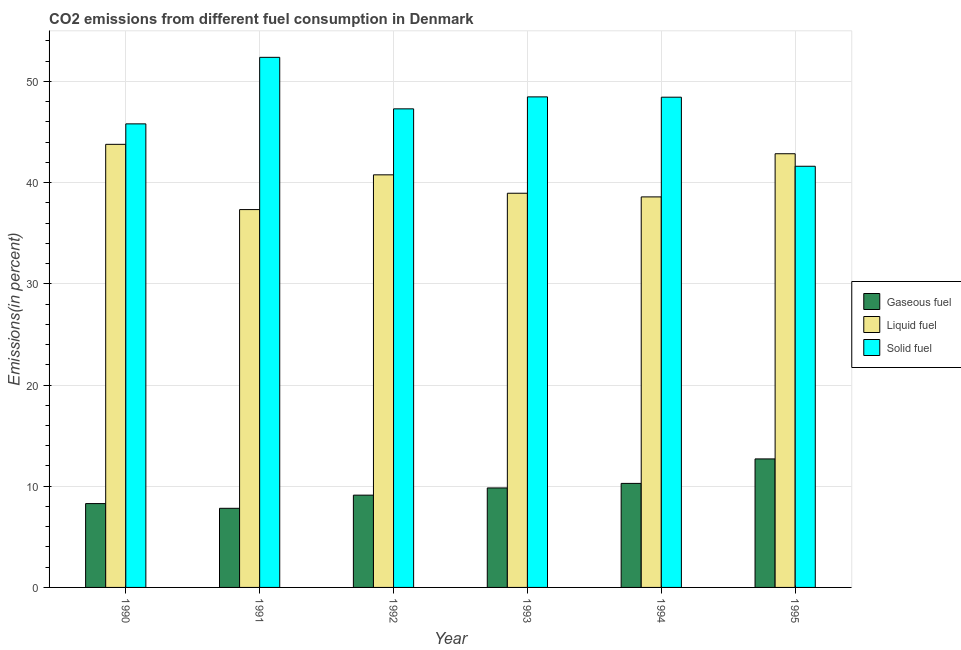How many different coloured bars are there?
Provide a short and direct response. 3. Are the number of bars per tick equal to the number of legend labels?
Your response must be concise. Yes. How many bars are there on the 2nd tick from the left?
Give a very brief answer. 3. What is the label of the 5th group of bars from the left?
Provide a succinct answer. 1994. In how many cases, is the number of bars for a given year not equal to the number of legend labels?
Offer a very short reply. 0. What is the percentage of gaseous fuel emission in 1995?
Make the answer very short. 12.7. Across all years, what is the maximum percentage of solid fuel emission?
Make the answer very short. 52.39. Across all years, what is the minimum percentage of liquid fuel emission?
Your response must be concise. 37.34. What is the total percentage of liquid fuel emission in the graph?
Your answer should be very brief. 242.3. What is the difference between the percentage of solid fuel emission in 1993 and that in 1995?
Give a very brief answer. 6.86. What is the difference between the percentage of liquid fuel emission in 1991 and the percentage of gaseous fuel emission in 1992?
Your response must be concise. -3.43. What is the average percentage of liquid fuel emission per year?
Your answer should be very brief. 40.38. What is the ratio of the percentage of liquid fuel emission in 1991 to that in 1995?
Give a very brief answer. 0.87. Is the percentage of liquid fuel emission in 1993 less than that in 1995?
Provide a succinct answer. Yes. Is the difference between the percentage of solid fuel emission in 1991 and 1992 greater than the difference between the percentage of liquid fuel emission in 1991 and 1992?
Keep it short and to the point. No. What is the difference between the highest and the second highest percentage of liquid fuel emission?
Ensure brevity in your answer.  0.93. What is the difference between the highest and the lowest percentage of gaseous fuel emission?
Your answer should be compact. 4.88. What does the 2nd bar from the left in 1992 represents?
Give a very brief answer. Liquid fuel. What does the 2nd bar from the right in 1994 represents?
Give a very brief answer. Liquid fuel. How many bars are there?
Give a very brief answer. 18. What is the difference between two consecutive major ticks on the Y-axis?
Provide a succinct answer. 10. Are the values on the major ticks of Y-axis written in scientific E-notation?
Your response must be concise. No. Does the graph contain any zero values?
Offer a terse response. No. Where does the legend appear in the graph?
Ensure brevity in your answer.  Center right. How are the legend labels stacked?
Offer a terse response. Vertical. What is the title of the graph?
Your answer should be very brief. CO2 emissions from different fuel consumption in Denmark. What is the label or title of the Y-axis?
Your response must be concise. Emissions(in percent). What is the Emissions(in percent) in Gaseous fuel in 1990?
Provide a succinct answer. 8.29. What is the Emissions(in percent) in Liquid fuel in 1990?
Provide a succinct answer. 43.79. What is the Emissions(in percent) in Solid fuel in 1990?
Ensure brevity in your answer.  45.81. What is the Emissions(in percent) in Gaseous fuel in 1991?
Ensure brevity in your answer.  7.82. What is the Emissions(in percent) of Liquid fuel in 1991?
Offer a terse response. 37.34. What is the Emissions(in percent) of Solid fuel in 1991?
Provide a succinct answer. 52.39. What is the Emissions(in percent) in Gaseous fuel in 1992?
Your answer should be very brief. 9.12. What is the Emissions(in percent) of Liquid fuel in 1992?
Provide a short and direct response. 40.77. What is the Emissions(in percent) of Solid fuel in 1992?
Keep it short and to the point. 47.29. What is the Emissions(in percent) in Gaseous fuel in 1993?
Your answer should be very brief. 9.83. What is the Emissions(in percent) in Liquid fuel in 1993?
Offer a very short reply. 38.95. What is the Emissions(in percent) of Solid fuel in 1993?
Offer a terse response. 48.48. What is the Emissions(in percent) in Gaseous fuel in 1994?
Make the answer very short. 10.28. What is the Emissions(in percent) of Liquid fuel in 1994?
Provide a short and direct response. 38.59. What is the Emissions(in percent) in Solid fuel in 1994?
Keep it short and to the point. 48.45. What is the Emissions(in percent) in Gaseous fuel in 1995?
Your response must be concise. 12.7. What is the Emissions(in percent) of Liquid fuel in 1995?
Offer a very short reply. 42.86. What is the Emissions(in percent) of Solid fuel in 1995?
Keep it short and to the point. 41.62. Across all years, what is the maximum Emissions(in percent) in Gaseous fuel?
Your response must be concise. 12.7. Across all years, what is the maximum Emissions(in percent) in Liquid fuel?
Your answer should be compact. 43.79. Across all years, what is the maximum Emissions(in percent) of Solid fuel?
Make the answer very short. 52.39. Across all years, what is the minimum Emissions(in percent) of Gaseous fuel?
Your answer should be compact. 7.82. Across all years, what is the minimum Emissions(in percent) in Liquid fuel?
Keep it short and to the point. 37.34. Across all years, what is the minimum Emissions(in percent) of Solid fuel?
Your answer should be compact. 41.62. What is the total Emissions(in percent) in Gaseous fuel in the graph?
Offer a very short reply. 58.03. What is the total Emissions(in percent) in Liquid fuel in the graph?
Offer a terse response. 242.3. What is the total Emissions(in percent) of Solid fuel in the graph?
Your response must be concise. 284.03. What is the difference between the Emissions(in percent) of Gaseous fuel in 1990 and that in 1991?
Provide a succinct answer. 0.47. What is the difference between the Emissions(in percent) of Liquid fuel in 1990 and that in 1991?
Provide a short and direct response. 6.45. What is the difference between the Emissions(in percent) of Solid fuel in 1990 and that in 1991?
Your answer should be very brief. -6.58. What is the difference between the Emissions(in percent) in Gaseous fuel in 1990 and that in 1992?
Provide a succinct answer. -0.83. What is the difference between the Emissions(in percent) in Liquid fuel in 1990 and that in 1992?
Make the answer very short. 3.02. What is the difference between the Emissions(in percent) in Solid fuel in 1990 and that in 1992?
Keep it short and to the point. -1.48. What is the difference between the Emissions(in percent) of Gaseous fuel in 1990 and that in 1993?
Offer a very short reply. -1.55. What is the difference between the Emissions(in percent) of Liquid fuel in 1990 and that in 1993?
Offer a terse response. 4.83. What is the difference between the Emissions(in percent) in Solid fuel in 1990 and that in 1993?
Offer a terse response. -2.67. What is the difference between the Emissions(in percent) in Gaseous fuel in 1990 and that in 1994?
Your answer should be very brief. -1.99. What is the difference between the Emissions(in percent) in Liquid fuel in 1990 and that in 1994?
Keep it short and to the point. 5.19. What is the difference between the Emissions(in percent) in Solid fuel in 1990 and that in 1994?
Offer a terse response. -2.64. What is the difference between the Emissions(in percent) of Gaseous fuel in 1990 and that in 1995?
Ensure brevity in your answer.  -4.41. What is the difference between the Emissions(in percent) of Liquid fuel in 1990 and that in 1995?
Provide a succinct answer. 0.93. What is the difference between the Emissions(in percent) of Solid fuel in 1990 and that in 1995?
Your response must be concise. 4.19. What is the difference between the Emissions(in percent) of Gaseous fuel in 1991 and that in 1992?
Your response must be concise. -1.3. What is the difference between the Emissions(in percent) of Liquid fuel in 1991 and that in 1992?
Offer a very short reply. -3.43. What is the difference between the Emissions(in percent) in Solid fuel in 1991 and that in 1992?
Give a very brief answer. 5.09. What is the difference between the Emissions(in percent) in Gaseous fuel in 1991 and that in 1993?
Keep it short and to the point. -2.01. What is the difference between the Emissions(in percent) of Liquid fuel in 1991 and that in 1993?
Provide a short and direct response. -1.62. What is the difference between the Emissions(in percent) in Solid fuel in 1991 and that in 1993?
Offer a terse response. 3.91. What is the difference between the Emissions(in percent) in Gaseous fuel in 1991 and that in 1994?
Keep it short and to the point. -2.46. What is the difference between the Emissions(in percent) of Liquid fuel in 1991 and that in 1994?
Your answer should be very brief. -1.25. What is the difference between the Emissions(in percent) of Solid fuel in 1991 and that in 1994?
Your answer should be very brief. 3.94. What is the difference between the Emissions(in percent) of Gaseous fuel in 1991 and that in 1995?
Your response must be concise. -4.88. What is the difference between the Emissions(in percent) of Liquid fuel in 1991 and that in 1995?
Ensure brevity in your answer.  -5.52. What is the difference between the Emissions(in percent) in Solid fuel in 1991 and that in 1995?
Offer a terse response. 10.76. What is the difference between the Emissions(in percent) of Gaseous fuel in 1992 and that in 1993?
Make the answer very short. -0.71. What is the difference between the Emissions(in percent) in Liquid fuel in 1992 and that in 1993?
Give a very brief answer. 1.82. What is the difference between the Emissions(in percent) in Solid fuel in 1992 and that in 1993?
Keep it short and to the point. -1.18. What is the difference between the Emissions(in percent) in Gaseous fuel in 1992 and that in 1994?
Provide a short and direct response. -1.16. What is the difference between the Emissions(in percent) of Liquid fuel in 1992 and that in 1994?
Provide a short and direct response. 2.18. What is the difference between the Emissions(in percent) of Solid fuel in 1992 and that in 1994?
Provide a succinct answer. -1.15. What is the difference between the Emissions(in percent) in Gaseous fuel in 1992 and that in 1995?
Your answer should be very brief. -3.58. What is the difference between the Emissions(in percent) in Liquid fuel in 1992 and that in 1995?
Your answer should be very brief. -2.09. What is the difference between the Emissions(in percent) in Solid fuel in 1992 and that in 1995?
Your answer should be very brief. 5.67. What is the difference between the Emissions(in percent) of Gaseous fuel in 1993 and that in 1994?
Give a very brief answer. -0.45. What is the difference between the Emissions(in percent) of Liquid fuel in 1993 and that in 1994?
Give a very brief answer. 0.36. What is the difference between the Emissions(in percent) in Solid fuel in 1993 and that in 1994?
Keep it short and to the point. 0.03. What is the difference between the Emissions(in percent) in Gaseous fuel in 1993 and that in 1995?
Ensure brevity in your answer.  -2.87. What is the difference between the Emissions(in percent) of Liquid fuel in 1993 and that in 1995?
Keep it short and to the point. -3.9. What is the difference between the Emissions(in percent) of Solid fuel in 1993 and that in 1995?
Offer a very short reply. 6.86. What is the difference between the Emissions(in percent) of Gaseous fuel in 1994 and that in 1995?
Provide a short and direct response. -2.42. What is the difference between the Emissions(in percent) of Liquid fuel in 1994 and that in 1995?
Give a very brief answer. -4.26. What is the difference between the Emissions(in percent) in Solid fuel in 1994 and that in 1995?
Make the answer very short. 6.83. What is the difference between the Emissions(in percent) of Gaseous fuel in 1990 and the Emissions(in percent) of Liquid fuel in 1991?
Give a very brief answer. -29.05. What is the difference between the Emissions(in percent) of Gaseous fuel in 1990 and the Emissions(in percent) of Solid fuel in 1991?
Your answer should be very brief. -44.1. What is the difference between the Emissions(in percent) in Liquid fuel in 1990 and the Emissions(in percent) in Solid fuel in 1991?
Your response must be concise. -8.6. What is the difference between the Emissions(in percent) in Gaseous fuel in 1990 and the Emissions(in percent) in Liquid fuel in 1992?
Your response must be concise. -32.49. What is the difference between the Emissions(in percent) in Gaseous fuel in 1990 and the Emissions(in percent) in Solid fuel in 1992?
Ensure brevity in your answer.  -39.01. What is the difference between the Emissions(in percent) in Liquid fuel in 1990 and the Emissions(in percent) in Solid fuel in 1992?
Your response must be concise. -3.51. What is the difference between the Emissions(in percent) of Gaseous fuel in 1990 and the Emissions(in percent) of Liquid fuel in 1993?
Your answer should be compact. -30.67. What is the difference between the Emissions(in percent) in Gaseous fuel in 1990 and the Emissions(in percent) in Solid fuel in 1993?
Give a very brief answer. -40.19. What is the difference between the Emissions(in percent) of Liquid fuel in 1990 and the Emissions(in percent) of Solid fuel in 1993?
Provide a succinct answer. -4.69. What is the difference between the Emissions(in percent) of Gaseous fuel in 1990 and the Emissions(in percent) of Liquid fuel in 1994?
Provide a succinct answer. -30.31. What is the difference between the Emissions(in percent) of Gaseous fuel in 1990 and the Emissions(in percent) of Solid fuel in 1994?
Provide a short and direct response. -40.16. What is the difference between the Emissions(in percent) in Liquid fuel in 1990 and the Emissions(in percent) in Solid fuel in 1994?
Make the answer very short. -4.66. What is the difference between the Emissions(in percent) of Gaseous fuel in 1990 and the Emissions(in percent) of Liquid fuel in 1995?
Provide a short and direct response. -34.57. What is the difference between the Emissions(in percent) of Gaseous fuel in 1990 and the Emissions(in percent) of Solid fuel in 1995?
Your answer should be compact. -33.33. What is the difference between the Emissions(in percent) in Liquid fuel in 1990 and the Emissions(in percent) in Solid fuel in 1995?
Provide a succinct answer. 2.17. What is the difference between the Emissions(in percent) in Gaseous fuel in 1991 and the Emissions(in percent) in Liquid fuel in 1992?
Keep it short and to the point. -32.95. What is the difference between the Emissions(in percent) in Gaseous fuel in 1991 and the Emissions(in percent) in Solid fuel in 1992?
Ensure brevity in your answer.  -39.47. What is the difference between the Emissions(in percent) in Liquid fuel in 1991 and the Emissions(in percent) in Solid fuel in 1992?
Keep it short and to the point. -9.95. What is the difference between the Emissions(in percent) in Gaseous fuel in 1991 and the Emissions(in percent) in Liquid fuel in 1993?
Make the answer very short. -31.14. What is the difference between the Emissions(in percent) of Gaseous fuel in 1991 and the Emissions(in percent) of Solid fuel in 1993?
Keep it short and to the point. -40.66. What is the difference between the Emissions(in percent) in Liquid fuel in 1991 and the Emissions(in percent) in Solid fuel in 1993?
Keep it short and to the point. -11.14. What is the difference between the Emissions(in percent) of Gaseous fuel in 1991 and the Emissions(in percent) of Liquid fuel in 1994?
Provide a succinct answer. -30.78. What is the difference between the Emissions(in percent) in Gaseous fuel in 1991 and the Emissions(in percent) in Solid fuel in 1994?
Keep it short and to the point. -40.63. What is the difference between the Emissions(in percent) in Liquid fuel in 1991 and the Emissions(in percent) in Solid fuel in 1994?
Your response must be concise. -11.11. What is the difference between the Emissions(in percent) in Gaseous fuel in 1991 and the Emissions(in percent) in Liquid fuel in 1995?
Offer a very short reply. -35.04. What is the difference between the Emissions(in percent) in Gaseous fuel in 1991 and the Emissions(in percent) in Solid fuel in 1995?
Provide a succinct answer. -33.8. What is the difference between the Emissions(in percent) of Liquid fuel in 1991 and the Emissions(in percent) of Solid fuel in 1995?
Make the answer very short. -4.28. What is the difference between the Emissions(in percent) in Gaseous fuel in 1992 and the Emissions(in percent) in Liquid fuel in 1993?
Your answer should be compact. -29.83. What is the difference between the Emissions(in percent) in Gaseous fuel in 1992 and the Emissions(in percent) in Solid fuel in 1993?
Your response must be concise. -39.36. What is the difference between the Emissions(in percent) in Liquid fuel in 1992 and the Emissions(in percent) in Solid fuel in 1993?
Offer a very short reply. -7.7. What is the difference between the Emissions(in percent) in Gaseous fuel in 1992 and the Emissions(in percent) in Liquid fuel in 1994?
Keep it short and to the point. -29.47. What is the difference between the Emissions(in percent) in Gaseous fuel in 1992 and the Emissions(in percent) in Solid fuel in 1994?
Keep it short and to the point. -39.33. What is the difference between the Emissions(in percent) of Liquid fuel in 1992 and the Emissions(in percent) of Solid fuel in 1994?
Keep it short and to the point. -7.67. What is the difference between the Emissions(in percent) of Gaseous fuel in 1992 and the Emissions(in percent) of Liquid fuel in 1995?
Keep it short and to the point. -33.74. What is the difference between the Emissions(in percent) in Gaseous fuel in 1992 and the Emissions(in percent) in Solid fuel in 1995?
Provide a short and direct response. -32.5. What is the difference between the Emissions(in percent) of Liquid fuel in 1992 and the Emissions(in percent) of Solid fuel in 1995?
Keep it short and to the point. -0.85. What is the difference between the Emissions(in percent) in Gaseous fuel in 1993 and the Emissions(in percent) in Liquid fuel in 1994?
Provide a succinct answer. -28.76. What is the difference between the Emissions(in percent) in Gaseous fuel in 1993 and the Emissions(in percent) in Solid fuel in 1994?
Provide a short and direct response. -38.61. What is the difference between the Emissions(in percent) in Liquid fuel in 1993 and the Emissions(in percent) in Solid fuel in 1994?
Your answer should be compact. -9.49. What is the difference between the Emissions(in percent) in Gaseous fuel in 1993 and the Emissions(in percent) in Liquid fuel in 1995?
Provide a short and direct response. -33.03. What is the difference between the Emissions(in percent) in Gaseous fuel in 1993 and the Emissions(in percent) in Solid fuel in 1995?
Make the answer very short. -31.79. What is the difference between the Emissions(in percent) in Liquid fuel in 1993 and the Emissions(in percent) in Solid fuel in 1995?
Provide a succinct answer. -2.67. What is the difference between the Emissions(in percent) of Gaseous fuel in 1994 and the Emissions(in percent) of Liquid fuel in 1995?
Your answer should be very brief. -32.58. What is the difference between the Emissions(in percent) of Gaseous fuel in 1994 and the Emissions(in percent) of Solid fuel in 1995?
Your answer should be very brief. -31.34. What is the difference between the Emissions(in percent) in Liquid fuel in 1994 and the Emissions(in percent) in Solid fuel in 1995?
Offer a terse response. -3.03. What is the average Emissions(in percent) in Gaseous fuel per year?
Offer a very short reply. 9.67. What is the average Emissions(in percent) in Liquid fuel per year?
Offer a terse response. 40.38. What is the average Emissions(in percent) of Solid fuel per year?
Make the answer very short. 47.34. In the year 1990, what is the difference between the Emissions(in percent) in Gaseous fuel and Emissions(in percent) in Liquid fuel?
Ensure brevity in your answer.  -35.5. In the year 1990, what is the difference between the Emissions(in percent) in Gaseous fuel and Emissions(in percent) in Solid fuel?
Offer a very short reply. -37.52. In the year 1990, what is the difference between the Emissions(in percent) of Liquid fuel and Emissions(in percent) of Solid fuel?
Offer a terse response. -2.02. In the year 1991, what is the difference between the Emissions(in percent) of Gaseous fuel and Emissions(in percent) of Liquid fuel?
Your response must be concise. -29.52. In the year 1991, what is the difference between the Emissions(in percent) in Gaseous fuel and Emissions(in percent) in Solid fuel?
Provide a succinct answer. -44.57. In the year 1991, what is the difference between the Emissions(in percent) in Liquid fuel and Emissions(in percent) in Solid fuel?
Offer a very short reply. -15.05. In the year 1992, what is the difference between the Emissions(in percent) of Gaseous fuel and Emissions(in percent) of Liquid fuel?
Offer a very short reply. -31.65. In the year 1992, what is the difference between the Emissions(in percent) in Gaseous fuel and Emissions(in percent) in Solid fuel?
Give a very brief answer. -38.17. In the year 1992, what is the difference between the Emissions(in percent) in Liquid fuel and Emissions(in percent) in Solid fuel?
Provide a short and direct response. -6.52. In the year 1993, what is the difference between the Emissions(in percent) in Gaseous fuel and Emissions(in percent) in Liquid fuel?
Keep it short and to the point. -29.12. In the year 1993, what is the difference between the Emissions(in percent) in Gaseous fuel and Emissions(in percent) in Solid fuel?
Make the answer very short. -38.65. In the year 1993, what is the difference between the Emissions(in percent) of Liquid fuel and Emissions(in percent) of Solid fuel?
Offer a very short reply. -9.52. In the year 1994, what is the difference between the Emissions(in percent) of Gaseous fuel and Emissions(in percent) of Liquid fuel?
Offer a very short reply. -28.31. In the year 1994, what is the difference between the Emissions(in percent) in Gaseous fuel and Emissions(in percent) in Solid fuel?
Offer a very short reply. -38.17. In the year 1994, what is the difference between the Emissions(in percent) in Liquid fuel and Emissions(in percent) in Solid fuel?
Your answer should be compact. -9.85. In the year 1995, what is the difference between the Emissions(in percent) in Gaseous fuel and Emissions(in percent) in Liquid fuel?
Give a very brief answer. -30.16. In the year 1995, what is the difference between the Emissions(in percent) in Gaseous fuel and Emissions(in percent) in Solid fuel?
Your answer should be compact. -28.92. In the year 1995, what is the difference between the Emissions(in percent) in Liquid fuel and Emissions(in percent) in Solid fuel?
Provide a short and direct response. 1.24. What is the ratio of the Emissions(in percent) in Gaseous fuel in 1990 to that in 1991?
Give a very brief answer. 1.06. What is the ratio of the Emissions(in percent) of Liquid fuel in 1990 to that in 1991?
Your answer should be compact. 1.17. What is the ratio of the Emissions(in percent) of Solid fuel in 1990 to that in 1991?
Offer a very short reply. 0.87. What is the ratio of the Emissions(in percent) of Gaseous fuel in 1990 to that in 1992?
Offer a very short reply. 0.91. What is the ratio of the Emissions(in percent) in Liquid fuel in 1990 to that in 1992?
Make the answer very short. 1.07. What is the ratio of the Emissions(in percent) in Solid fuel in 1990 to that in 1992?
Offer a very short reply. 0.97. What is the ratio of the Emissions(in percent) of Gaseous fuel in 1990 to that in 1993?
Offer a very short reply. 0.84. What is the ratio of the Emissions(in percent) in Liquid fuel in 1990 to that in 1993?
Your response must be concise. 1.12. What is the ratio of the Emissions(in percent) in Solid fuel in 1990 to that in 1993?
Give a very brief answer. 0.94. What is the ratio of the Emissions(in percent) of Gaseous fuel in 1990 to that in 1994?
Give a very brief answer. 0.81. What is the ratio of the Emissions(in percent) of Liquid fuel in 1990 to that in 1994?
Your response must be concise. 1.13. What is the ratio of the Emissions(in percent) in Solid fuel in 1990 to that in 1994?
Keep it short and to the point. 0.95. What is the ratio of the Emissions(in percent) of Gaseous fuel in 1990 to that in 1995?
Ensure brevity in your answer.  0.65. What is the ratio of the Emissions(in percent) of Liquid fuel in 1990 to that in 1995?
Keep it short and to the point. 1.02. What is the ratio of the Emissions(in percent) in Solid fuel in 1990 to that in 1995?
Give a very brief answer. 1.1. What is the ratio of the Emissions(in percent) in Gaseous fuel in 1991 to that in 1992?
Give a very brief answer. 0.86. What is the ratio of the Emissions(in percent) of Liquid fuel in 1991 to that in 1992?
Provide a succinct answer. 0.92. What is the ratio of the Emissions(in percent) of Solid fuel in 1991 to that in 1992?
Give a very brief answer. 1.11. What is the ratio of the Emissions(in percent) in Gaseous fuel in 1991 to that in 1993?
Provide a short and direct response. 0.8. What is the ratio of the Emissions(in percent) in Liquid fuel in 1991 to that in 1993?
Ensure brevity in your answer.  0.96. What is the ratio of the Emissions(in percent) in Solid fuel in 1991 to that in 1993?
Make the answer very short. 1.08. What is the ratio of the Emissions(in percent) in Gaseous fuel in 1991 to that in 1994?
Keep it short and to the point. 0.76. What is the ratio of the Emissions(in percent) in Liquid fuel in 1991 to that in 1994?
Offer a terse response. 0.97. What is the ratio of the Emissions(in percent) in Solid fuel in 1991 to that in 1994?
Your answer should be compact. 1.08. What is the ratio of the Emissions(in percent) of Gaseous fuel in 1991 to that in 1995?
Offer a very short reply. 0.62. What is the ratio of the Emissions(in percent) of Liquid fuel in 1991 to that in 1995?
Provide a succinct answer. 0.87. What is the ratio of the Emissions(in percent) of Solid fuel in 1991 to that in 1995?
Your answer should be very brief. 1.26. What is the ratio of the Emissions(in percent) in Gaseous fuel in 1992 to that in 1993?
Provide a succinct answer. 0.93. What is the ratio of the Emissions(in percent) of Liquid fuel in 1992 to that in 1993?
Your response must be concise. 1.05. What is the ratio of the Emissions(in percent) of Solid fuel in 1992 to that in 1993?
Keep it short and to the point. 0.98. What is the ratio of the Emissions(in percent) in Gaseous fuel in 1992 to that in 1994?
Provide a succinct answer. 0.89. What is the ratio of the Emissions(in percent) of Liquid fuel in 1992 to that in 1994?
Your answer should be compact. 1.06. What is the ratio of the Emissions(in percent) of Solid fuel in 1992 to that in 1994?
Your answer should be very brief. 0.98. What is the ratio of the Emissions(in percent) of Gaseous fuel in 1992 to that in 1995?
Your answer should be compact. 0.72. What is the ratio of the Emissions(in percent) of Liquid fuel in 1992 to that in 1995?
Keep it short and to the point. 0.95. What is the ratio of the Emissions(in percent) in Solid fuel in 1992 to that in 1995?
Ensure brevity in your answer.  1.14. What is the ratio of the Emissions(in percent) in Gaseous fuel in 1993 to that in 1994?
Your answer should be compact. 0.96. What is the ratio of the Emissions(in percent) of Liquid fuel in 1993 to that in 1994?
Ensure brevity in your answer.  1.01. What is the ratio of the Emissions(in percent) of Solid fuel in 1993 to that in 1994?
Your answer should be very brief. 1. What is the ratio of the Emissions(in percent) in Gaseous fuel in 1993 to that in 1995?
Keep it short and to the point. 0.77. What is the ratio of the Emissions(in percent) in Liquid fuel in 1993 to that in 1995?
Make the answer very short. 0.91. What is the ratio of the Emissions(in percent) of Solid fuel in 1993 to that in 1995?
Keep it short and to the point. 1.16. What is the ratio of the Emissions(in percent) of Gaseous fuel in 1994 to that in 1995?
Your answer should be very brief. 0.81. What is the ratio of the Emissions(in percent) in Liquid fuel in 1994 to that in 1995?
Your response must be concise. 0.9. What is the ratio of the Emissions(in percent) of Solid fuel in 1994 to that in 1995?
Make the answer very short. 1.16. What is the difference between the highest and the second highest Emissions(in percent) of Gaseous fuel?
Your response must be concise. 2.42. What is the difference between the highest and the second highest Emissions(in percent) in Liquid fuel?
Keep it short and to the point. 0.93. What is the difference between the highest and the second highest Emissions(in percent) of Solid fuel?
Give a very brief answer. 3.91. What is the difference between the highest and the lowest Emissions(in percent) of Gaseous fuel?
Your response must be concise. 4.88. What is the difference between the highest and the lowest Emissions(in percent) of Liquid fuel?
Make the answer very short. 6.45. What is the difference between the highest and the lowest Emissions(in percent) in Solid fuel?
Offer a terse response. 10.76. 